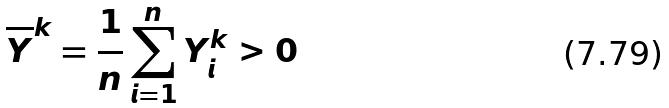Convert formula to latex. <formula><loc_0><loc_0><loc_500><loc_500>\overline { Y } ^ { k } = \frac { 1 } { n } \sum _ { i = 1 } ^ { n } Y _ { i } ^ { k } > 0</formula> 